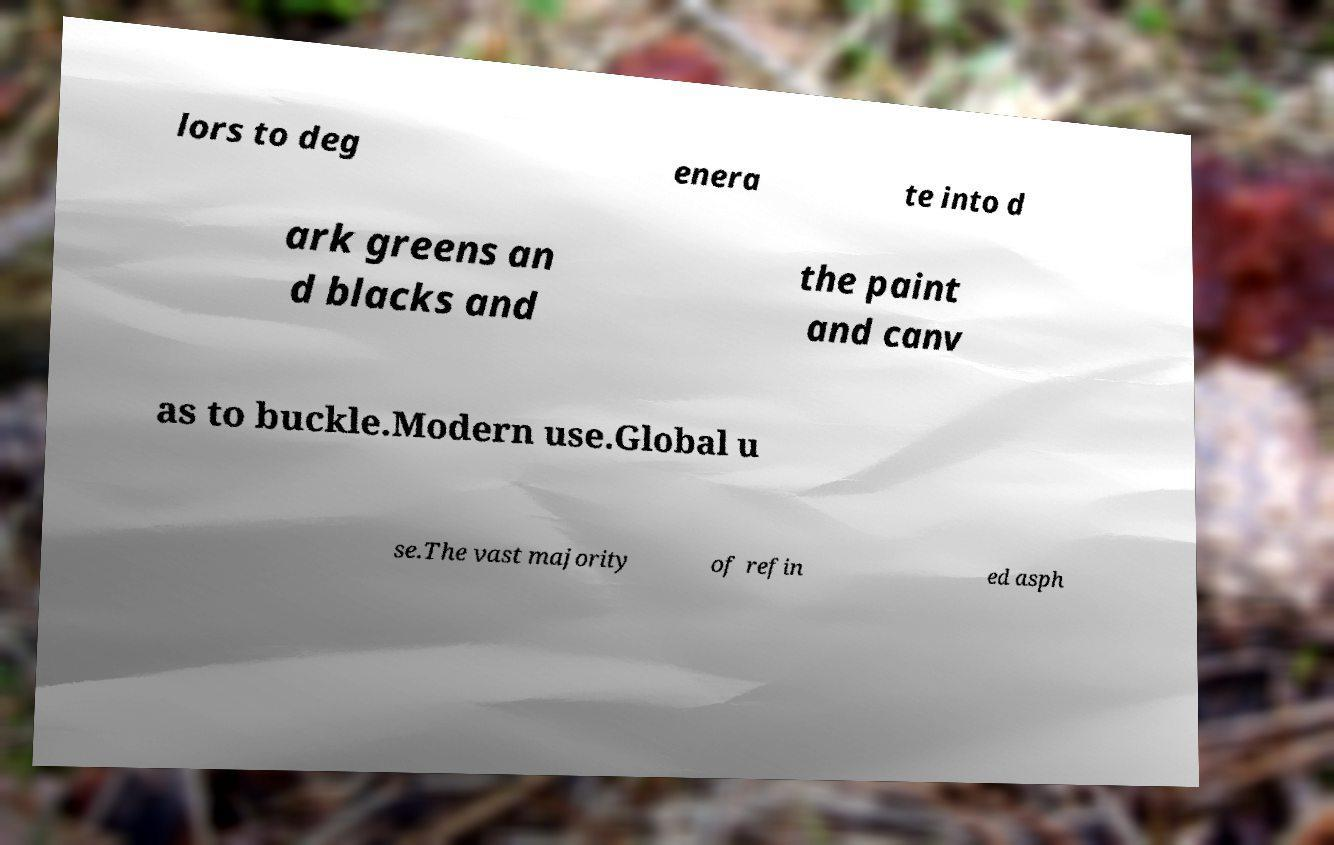Please read and relay the text visible in this image. What does it say? lors to deg enera te into d ark greens an d blacks and the paint and canv as to buckle.Modern use.Global u se.The vast majority of refin ed asph 